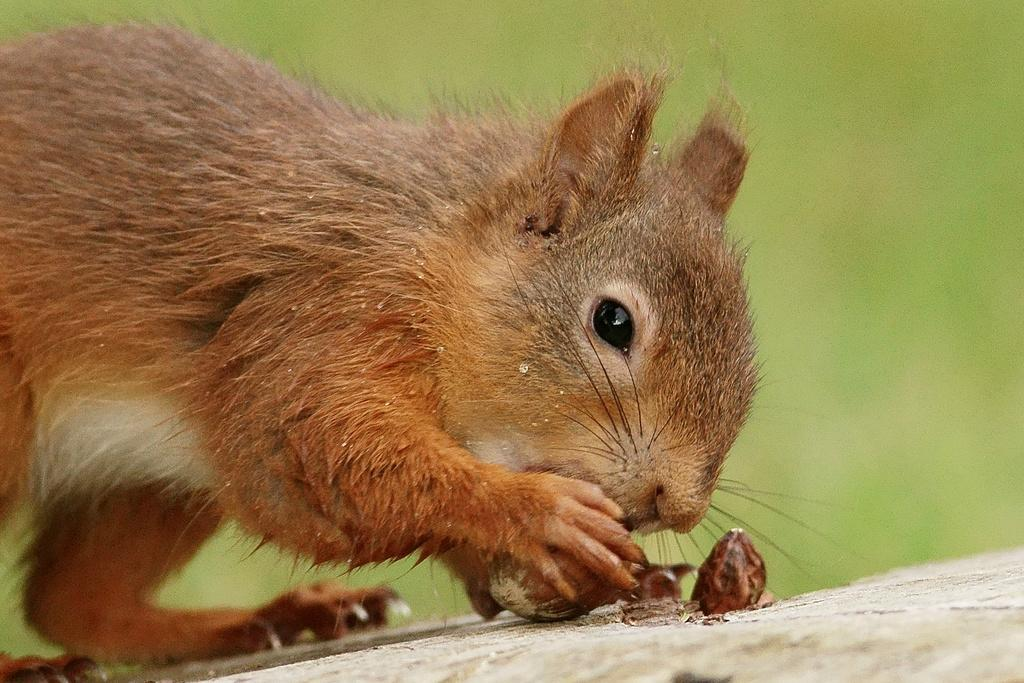What animal is present in the image? There is a squirrel in the image. What is the squirrel holding in its hand? The squirrel is holding something in its hand. Can you describe the background of the image? The background of the image is blurry. What type of agreement is being discussed by the group of squirrels in the image? There is no group of squirrels present in the image, and therefore no discussion or agreement can be observed. 